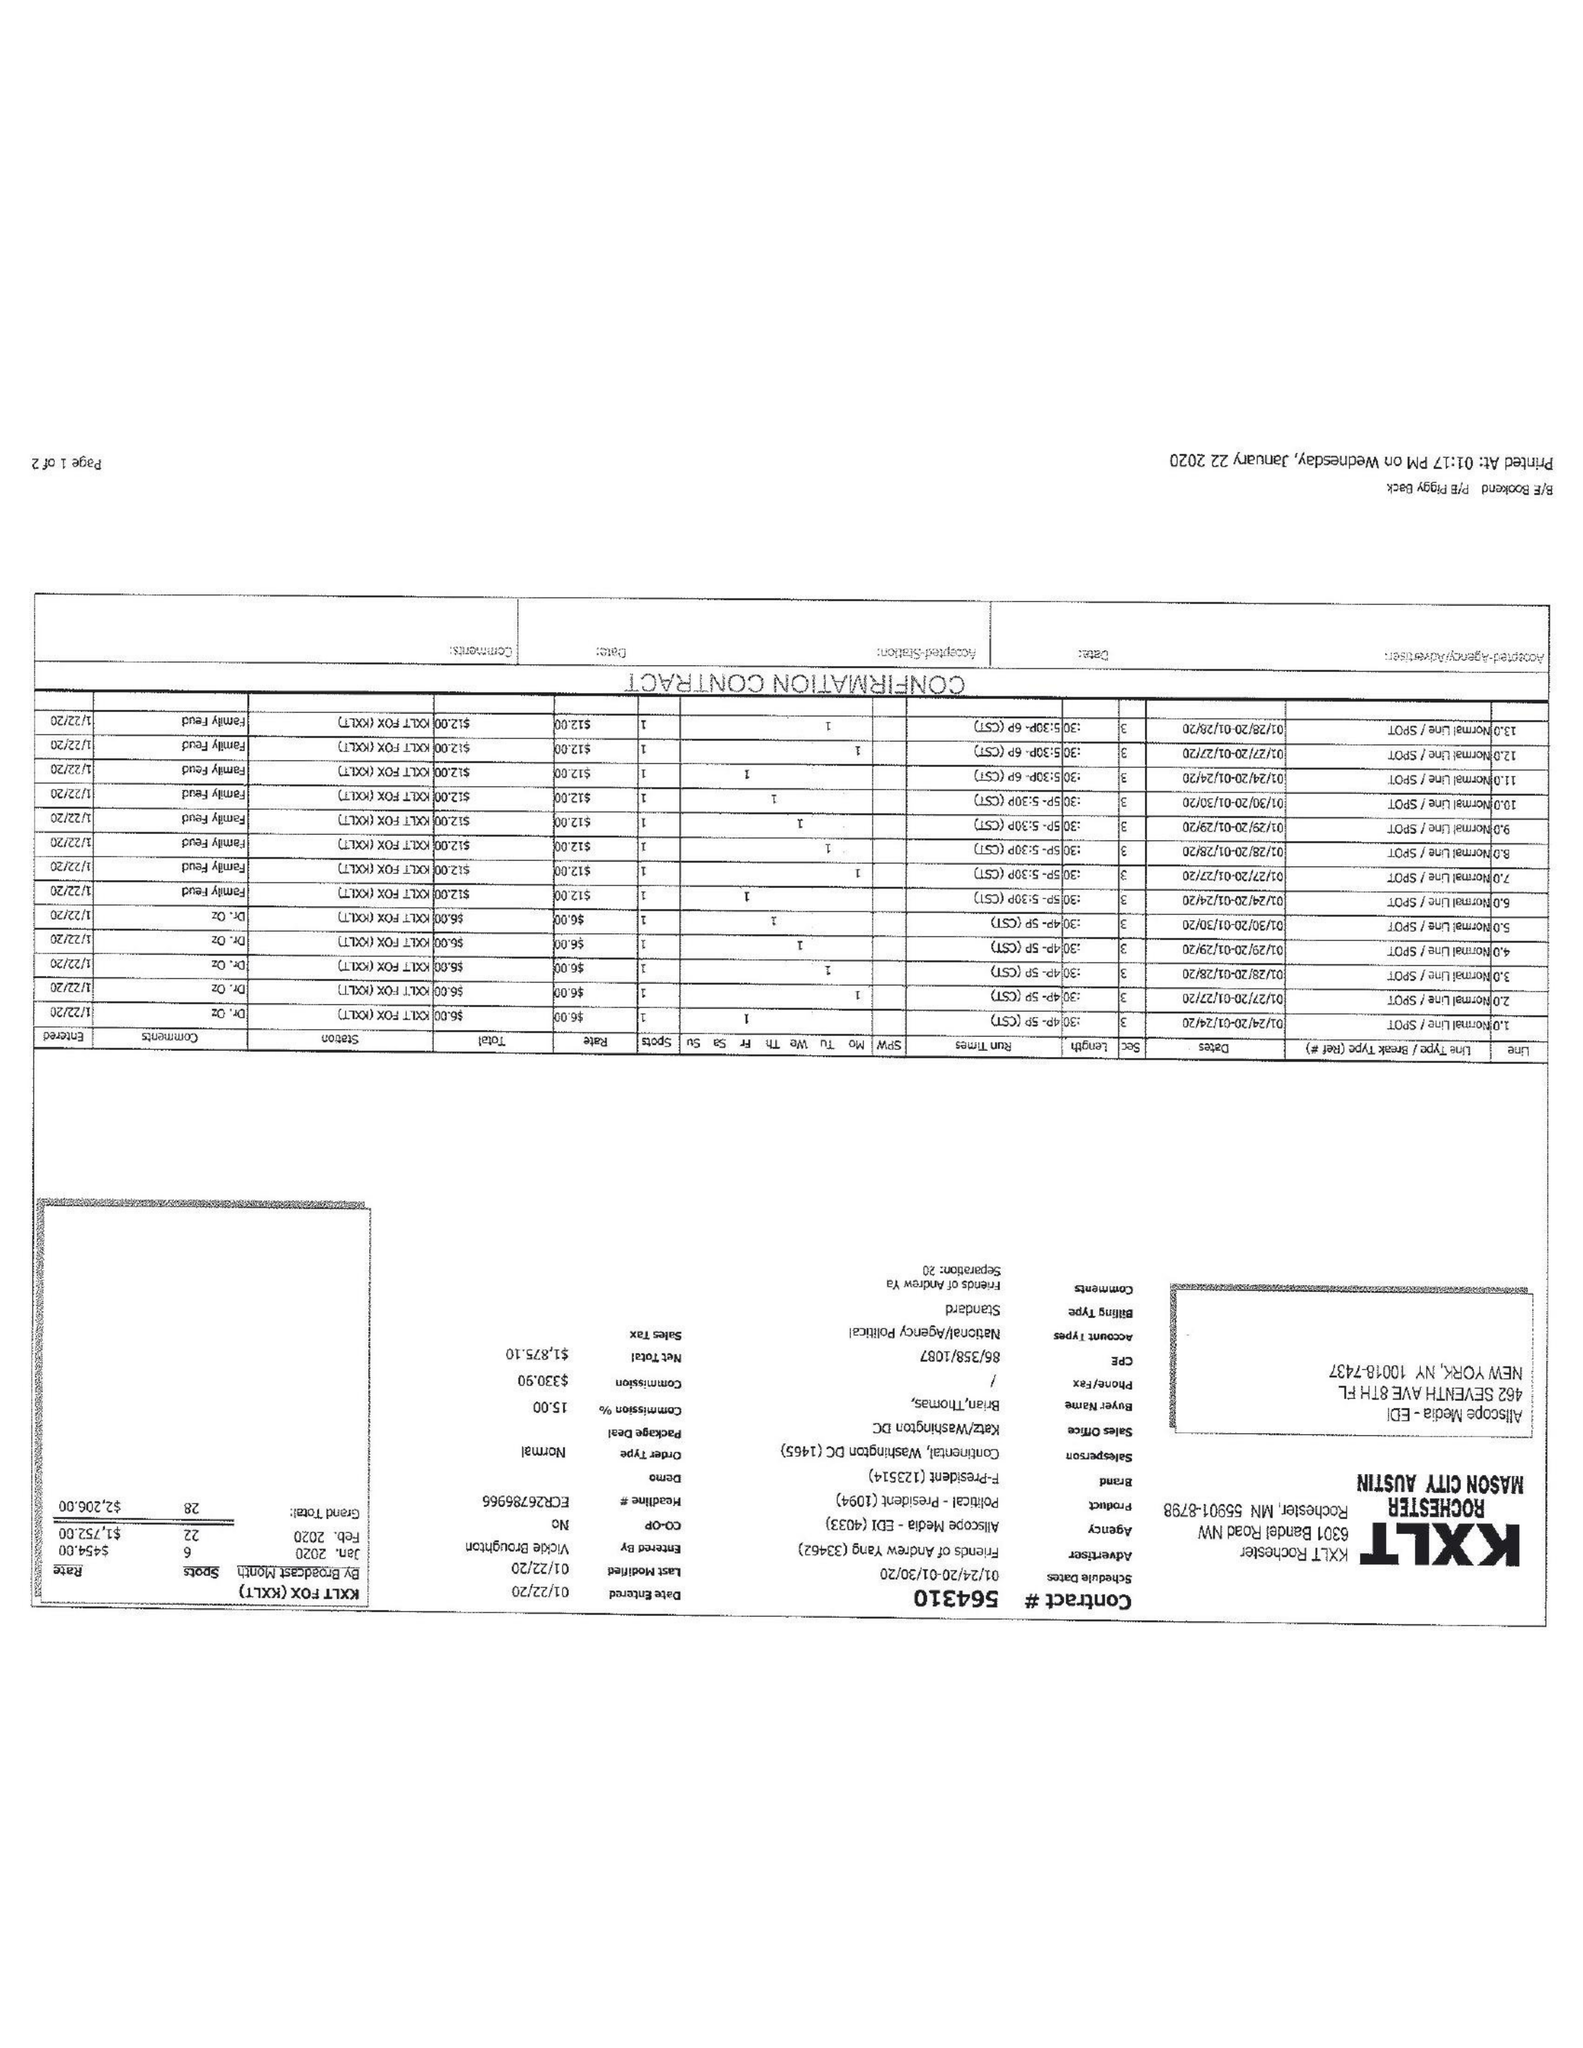What is the value for the flight_to?
Answer the question using a single word or phrase. 01/30/20 